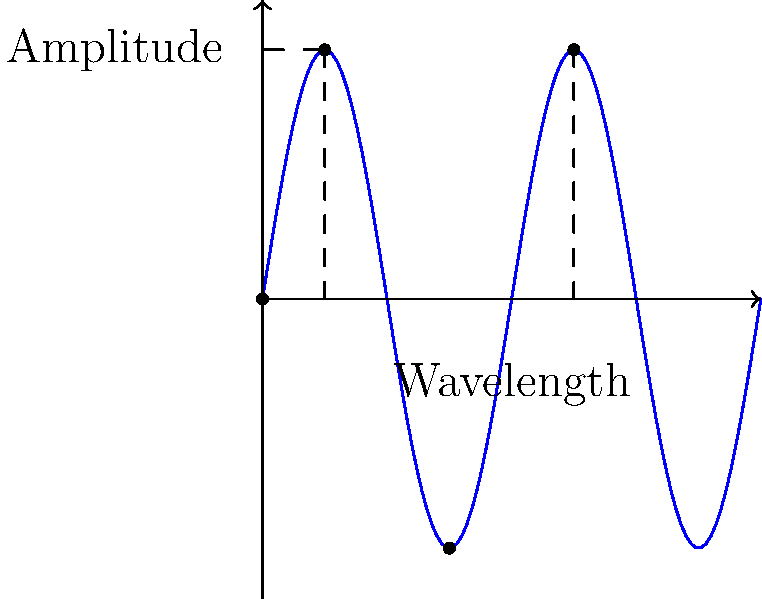In the context of audio processing for DJing, a sound wave is often visualized as a sine curve. Given the graph above representing a sound wave, determine the wavelength of this periodic signal. Assume the x-axis represents time in seconds and the y-axis represents amplitude. To determine the wavelength of the sine curve, we need to follow these steps:

1) In a sine wave, the wavelength is the distance between two consecutive peaks (or troughs).

2) On the graph, we can see that the wave completes one full cycle between x = 0 and x = 1.

3) This is evident from:
   - The wave starts at y = 0 when x = 0
   - It reaches its first peak at x = 0.25
   - It reaches its trough at x = 0.75
   - It completes the cycle by reaching the next peak at x = 1.25

4) The distance between these two peaks (x = 0.25 and x = 1.25) is exactly 1 unit on the x-axis.

5) Since the x-axis represents time in seconds, the wavelength of this sound wave is 1 second.

Understanding wavelength is crucial for a DJ as it relates to the frequency of the sound. A shorter wavelength corresponds to a higher frequency (higher pitch), while a longer wavelength corresponds to a lower frequency (lower pitch). This knowledge can be applied when mixing tracks or creating transitions between songs with different pitch characteristics.
Answer: 1 second 